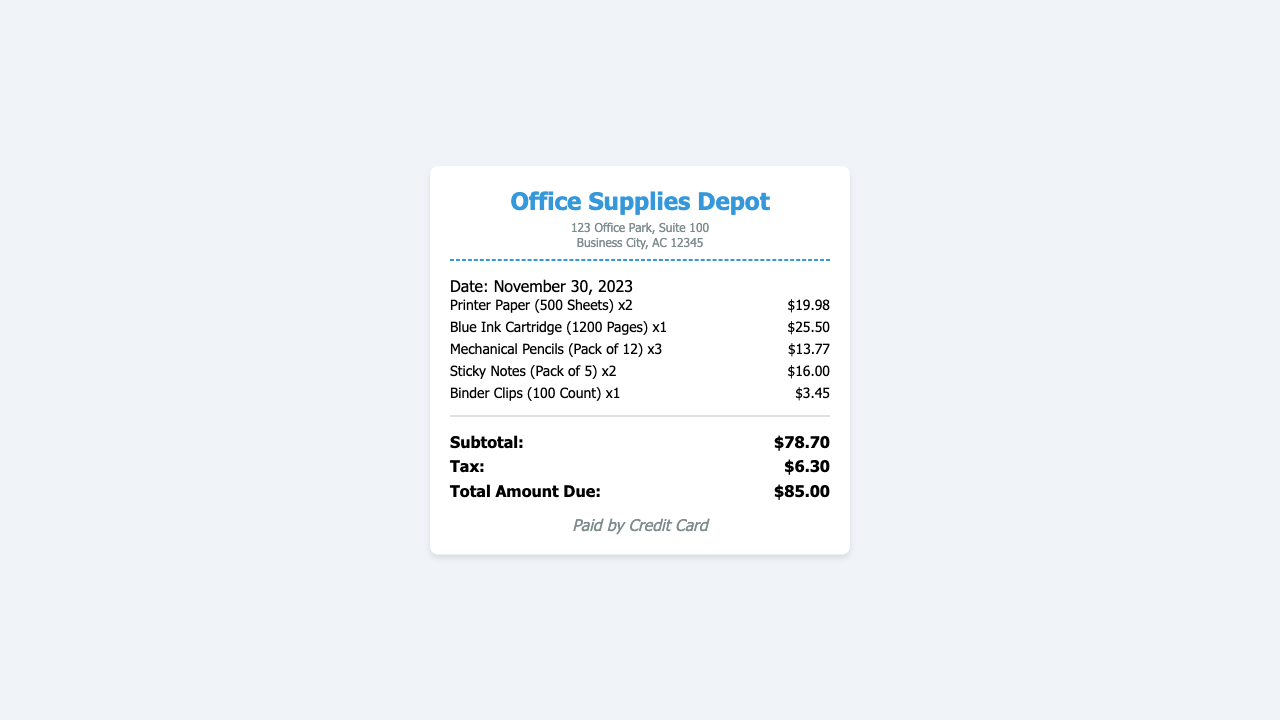What is the date of the receipt? The receipt states the date at the top, which is November 30, 2023.
Answer: November 30, 2023 What is the name of the supplier? The supplier's name is indicated at the top of the receipt as "Office Supplies Depot."
Answer: Office Supplies Depot How much did the Blue Ink Cartridge cost? The price of the Blue Ink Cartridge is listed next to the item details, which is $25.50.
Answer: $25.50 What is the subtotal of the receipt? The subtotal is provided towards the end of the receipt, specifically labeled, and is $78.70.
Answer: $78.70 How many packs of Mechanical Pencils were purchased? The receipt indicates that 3 packs of Mechanical Pencils were bought.
Answer: 3 What is the total amount due? The total amount due is calculated and presented at the end of the receipt, which is $85.00.
Answer: $85.00 What method of payment was used? The method of payment is mentioned at the bottom of the receipt, stating it was "Paid by Credit Card."
Answer: Paid by Credit Card How many sheets are in each pack of Printer Paper? The receipt notes that each Printer Paper pack contains 500 Sheets.
Answer: 500 Sheets How much did the Sticky Notes cost in total? The total cost for the Sticky Notes is calculated as $16.00 for 2 packs.
Answer: $16.00 